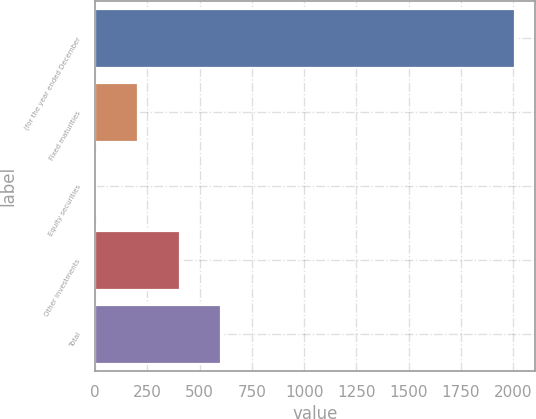Convert chart. <chart><loc_0><loc_0><loc_500><loc_500><bar_chart><fcel>(for the year ended December<fcel>Fixed maturities<fcel>Equity securities<fcel>Other investments<fcel>Total<nl><fcel>2006<fcel>204.2<fcel>4<fcel>404.4<fcel>604.6<nl></chart> 